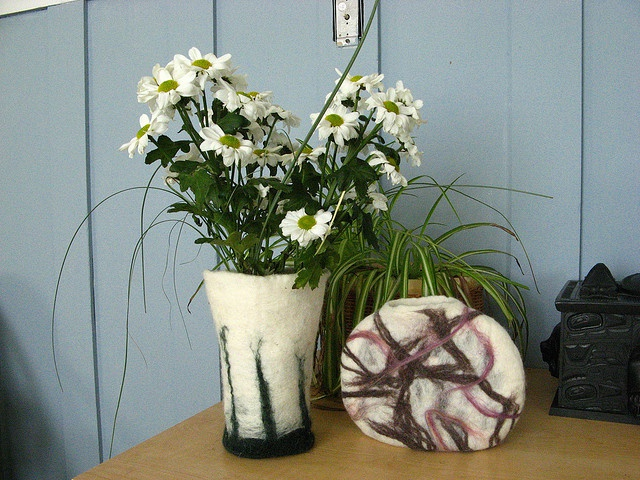Describe the objects in this image and their specific colors. I can see potted plant in lightgray, black, gray, and darkgreen tones, vase in lightgray, darkgray, beige, gray, and maroon tones, dining table in lightgray, gray, and olive tones, and vase in lightgray, beige, black, and darkgray tones in this image. 